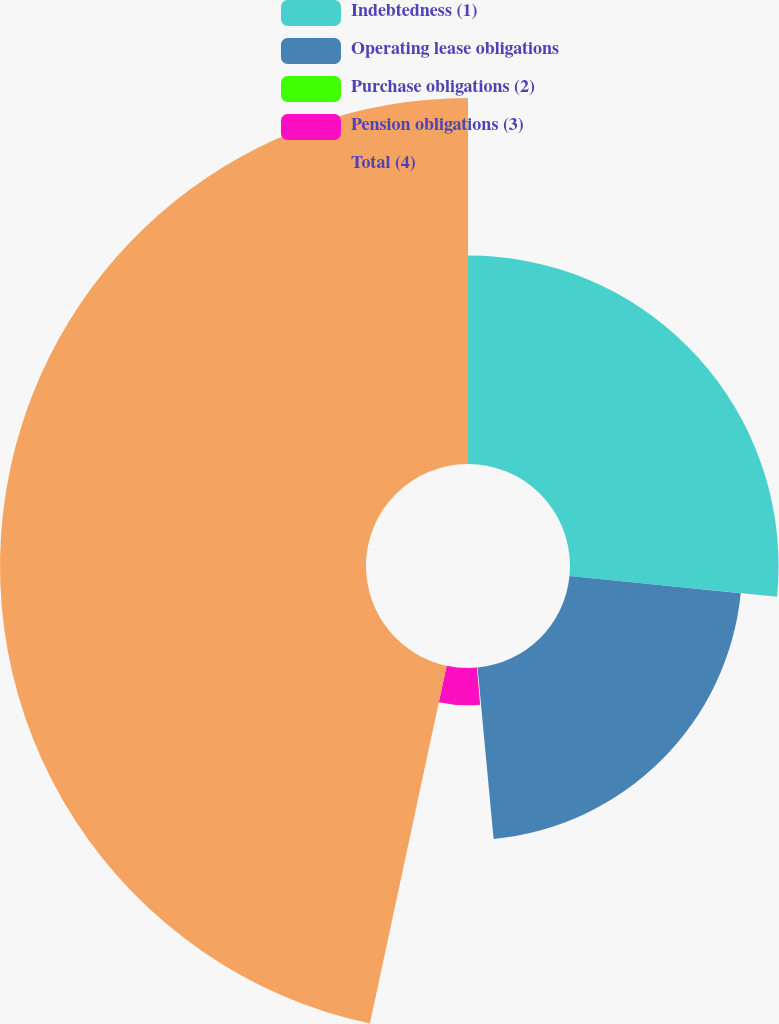<chart> <loc_0><loc_0><loc_500><loc_500><pie_chart><fcel>Indebtedness (1)<fcel>Operating lease obligations<fcel>Purchase obligations (2)<fcel>Pension obligations (3)<fcel>Total (4)<nl><fcel>26.58%<fcel>21.93%<fcel>0.1%<fcel>4.75%<fcel>46.64%<nl></chart> 